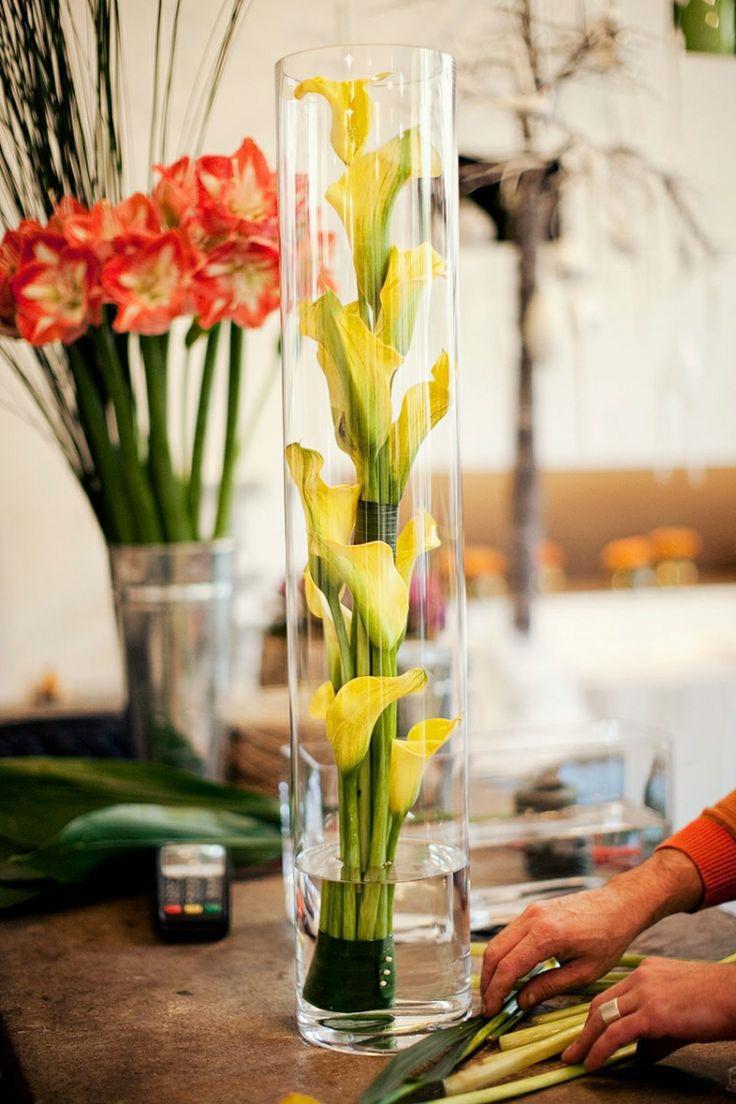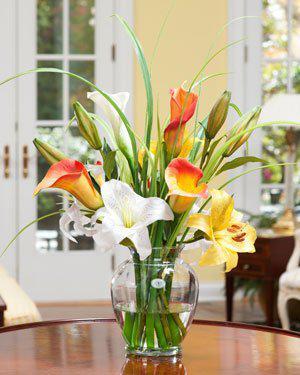The first image is the image on the left, the second image is the image on the right. Given the left and right images, does the statement "Yellow flowers sit in some of the vases." hold true? Answer yes or no. Yes. The first image is the image on the left, the second image is the image on the right. Given the left and right images, does the statement "One image includes a clear glass vase containing only bright yellow flowers standing in water." hold true? Answer yes or no. Yes. 